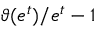Convert formula to latex. <formula><loc_0><loc_0><loc_500><loc_500>\vartheta ( e ^ { t } ) / { e ^ { t } } - 1</formula> 